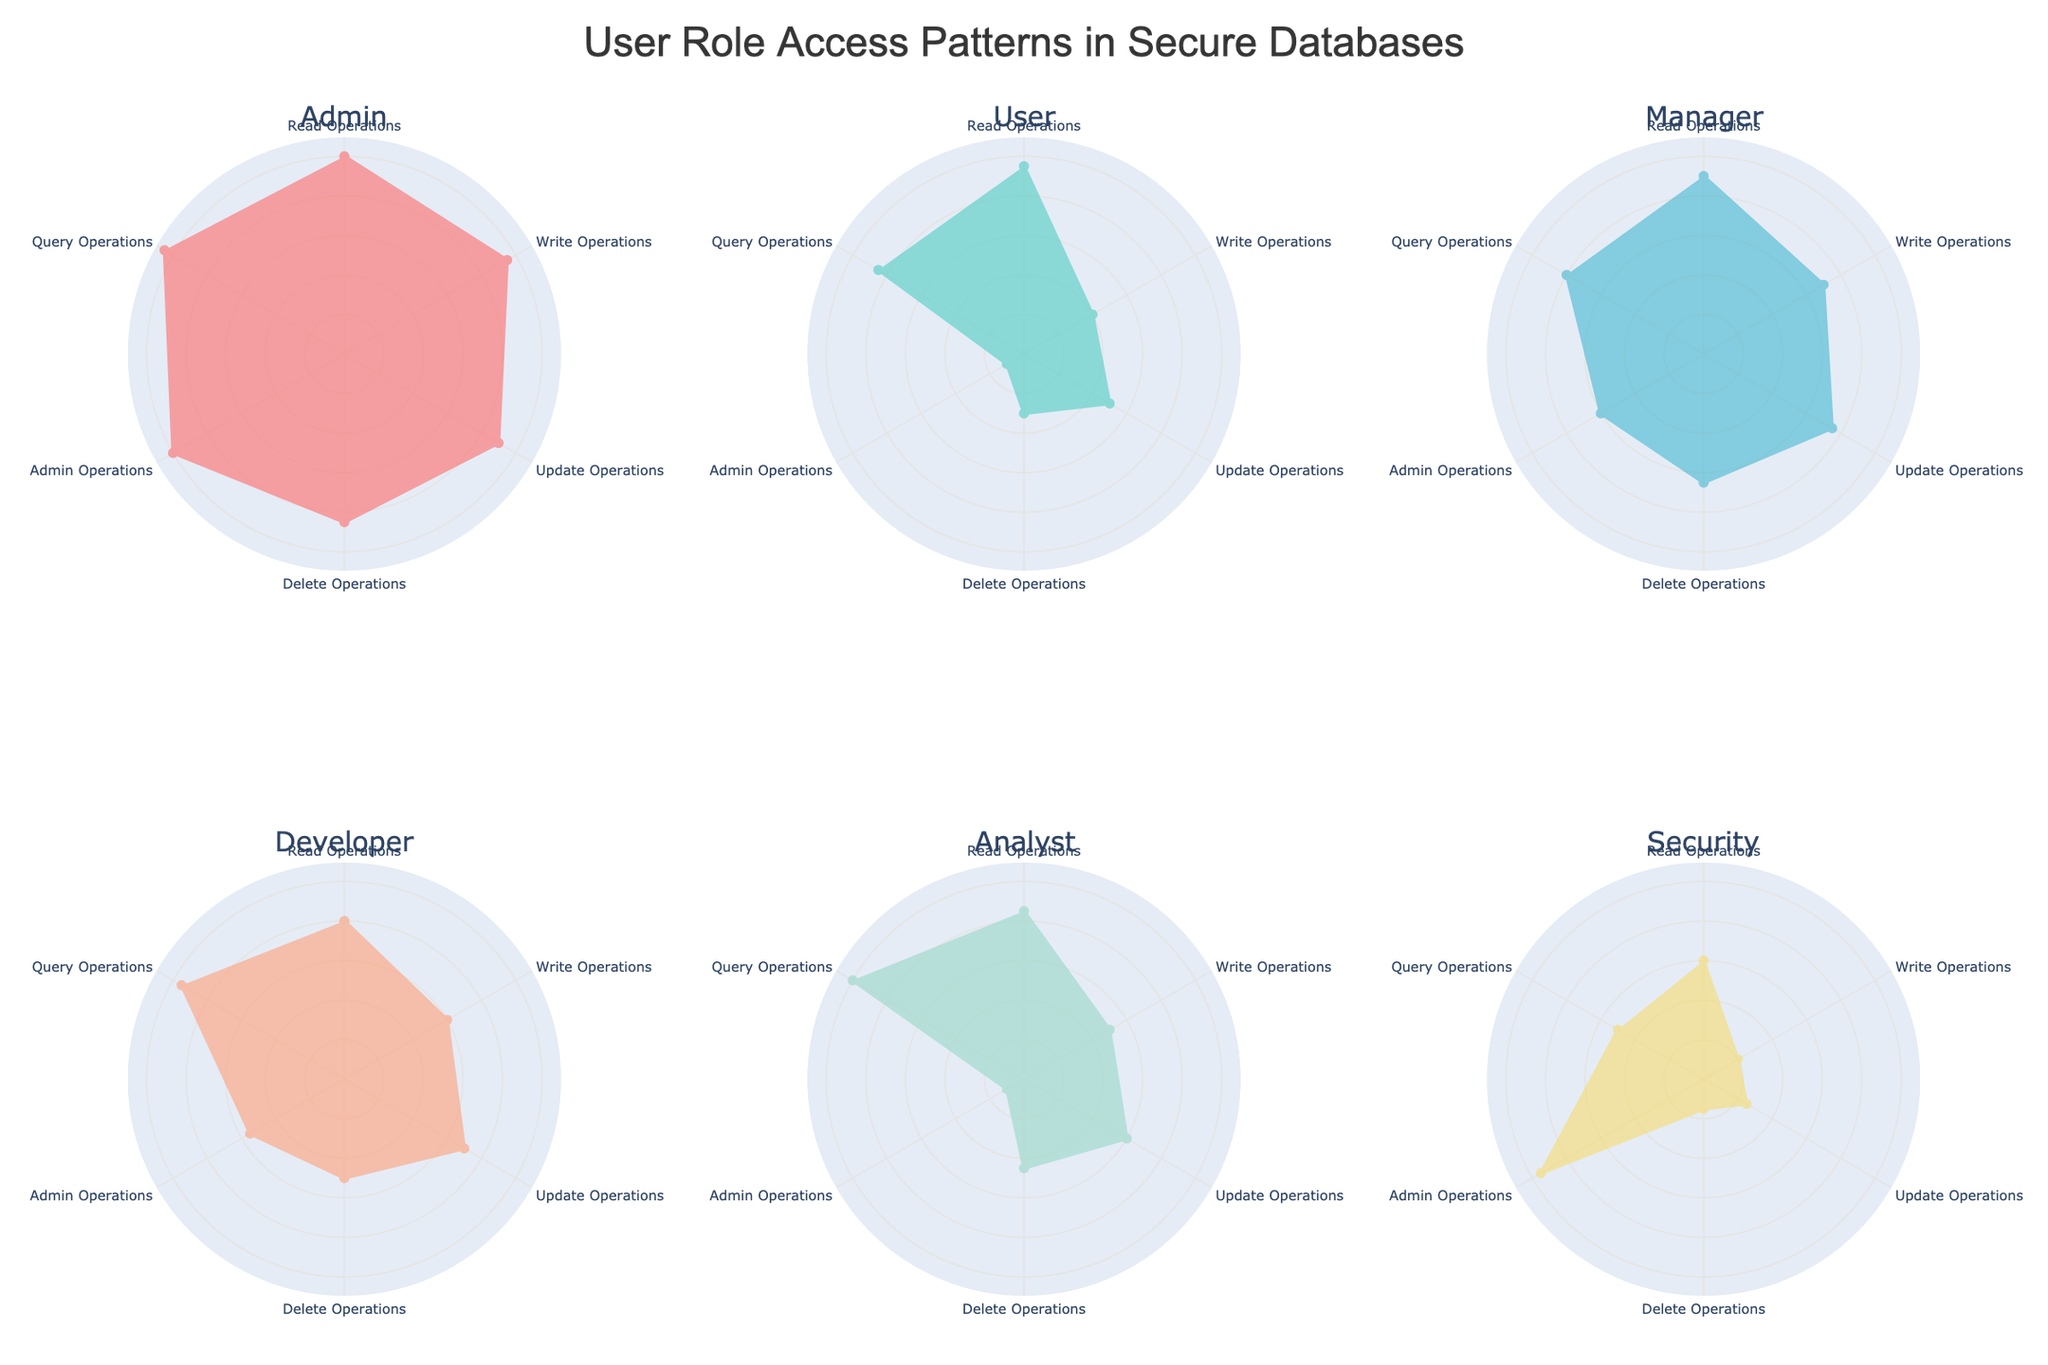What is the title of the figure? The title is usually the largest and most prominent text at the top of the figure. It provides a summary of what the figure is about.
Answer: User Role Access Patterns in Secure Databases How many subplots are there in the figure? The figure has different charts for each user role, arranged in a grid pattern. By counting these, we can determine the total number of subplots.
Answer: 6 Which role has the highest number of write operations? Look at the radial points labeled "Write Operations" for all subplots and compare the values. The one that extends the furthest in the "Write Operations" direction is the highest.
Answer: Admin What is the sum of read and write operations for the Manager role? Locate the Manager subplot and sum the values of read operations (90) and write operations (70).
Answer: 160 Which role has the lowest delete operations? Compare the radial points labeled "Delete Operations" in each subplot. The one with the smallest value represents the lowest delete operations.
Answer: Security How do read operations for the Analyst compare with those for the Developer? Compare the "Read Operations" radial points in the Analyst and Developer subplots. The one with the larger value has more read operations.
Answer: Analyst has 5 more read operations than Developer What's the difference between query operations in the User role and the Security role? Subtract the query operations value for the Security role (50) from the value for the User role (85).
Answer: 35 Which roles have higher than 90 read operations? Examine the “Read Operations” radial points for all roles. List the roles where the values are greater than 90.
Answer: Admin, User, Manager Which role has more admin operations, Security or Manager? Compare the "Admin Operations" radial points in the Security and Manager subplots. The one with the larger value has more admin operations.
Answer: Security What is the average of update operations across all roles? Sum up the update operations values for all roles (90 + 50 + 75 + 70 + 60 + 25) and divide by the number of roles (6). (90 + 50 + 75 + 70 + 60 + 25) / 6 = 370 / 6.
Answer: 61.67 